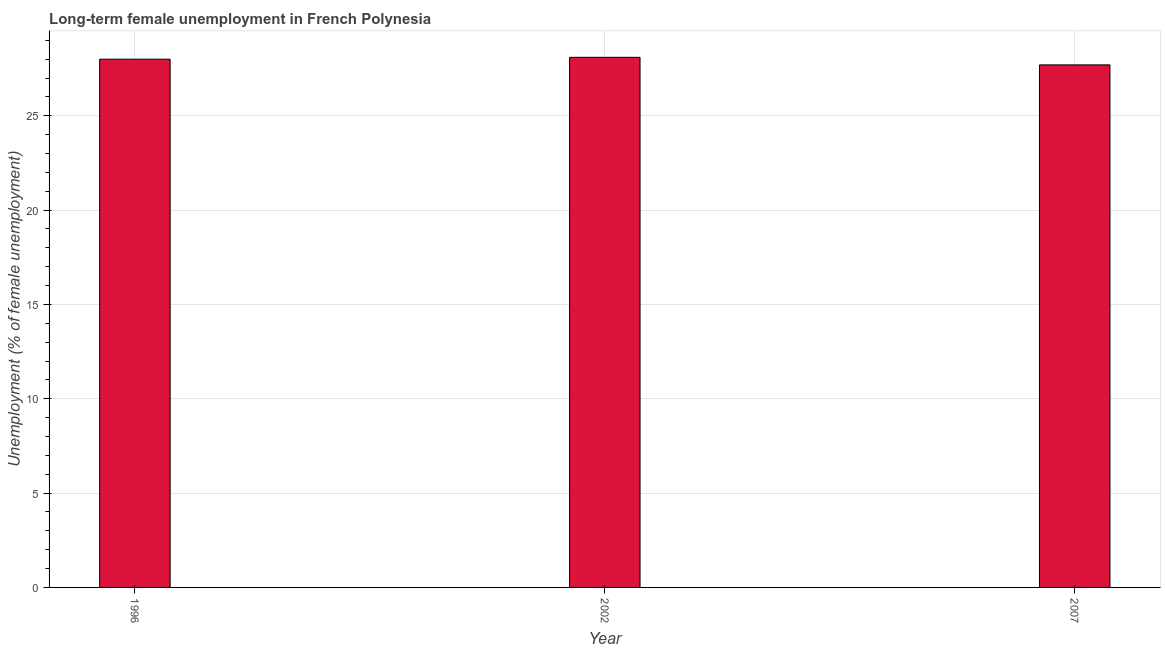What is the title of the graph?
Give a very brief answer. Long-term female unemployment in French Polynesia. What is the label or title of the X-axis?
Your answer should be very brief. Year. What is the label or title of the Y-axis?
Make the answer very short. Unemployment (% of female unemployment). What is the long-term female unemployment in 2002?
Give a very brief answer. 28.1. Across all years, what is the maximum long-term female unemployment?
Make the answer very short. 28.1. Across all years, what is the minimum long-term female unemployment?
Provide a short and direct response. 27.7. In which year was the long-term female unemployment maximum?
Make the answer very short. 2002. What is the sum of the long-term female unemployment?
Give a very brief answer. 83.8. What is the average long-term female unemployment per year?
Give a very brief answer. 27.93. In how many years, is the long-term female unemployment greater than 5 %?
Your response must be concise. 3. What is the ratio of the long-term female unemployment in 1996 to that in 2002?
Keep it short and to the point. 1. Is the long-term female unemployment in 1996 less than that in 2007?
Make the answer very short. No. Is the difference between the long-term female unemployment in 1996 and 2007 greater than the difference between any two years?
Provide a short and direct response. No. What is the difference between the highest and the second highest long-term female unemployment?
Ensure brevity in your answer.  0.1. How many years are there in the graph?
Provide a succinct answer. 3. What is the difference between two consecutive major ticks on the Y-axis?
Make the answer very short. 5. What is the Unemployment (% of female unemployment) of 2002?
Provide a short and direct response. 28.1. What is the Unemployment (% of female unemployment) in 2007?
Your answer should be very brief. 27.7. What is the difference between the Unemployment (% of female unemployment) in 1996 and 2002?
Make the answer very short. -0.1. What is the difference between the Unemployment (% of female unemployment) in 1996 and 2007?
Make the answer very short. 0.3. What is the difference between the Unemployment (% of female unemployment) in 2002 and 2007?
Your answer should be very brief. 0.4. What is the ratio of the Unemployment (% of female unemployment) in 1996 to that in 2002?
Ensure brevity in your answer.  1. 